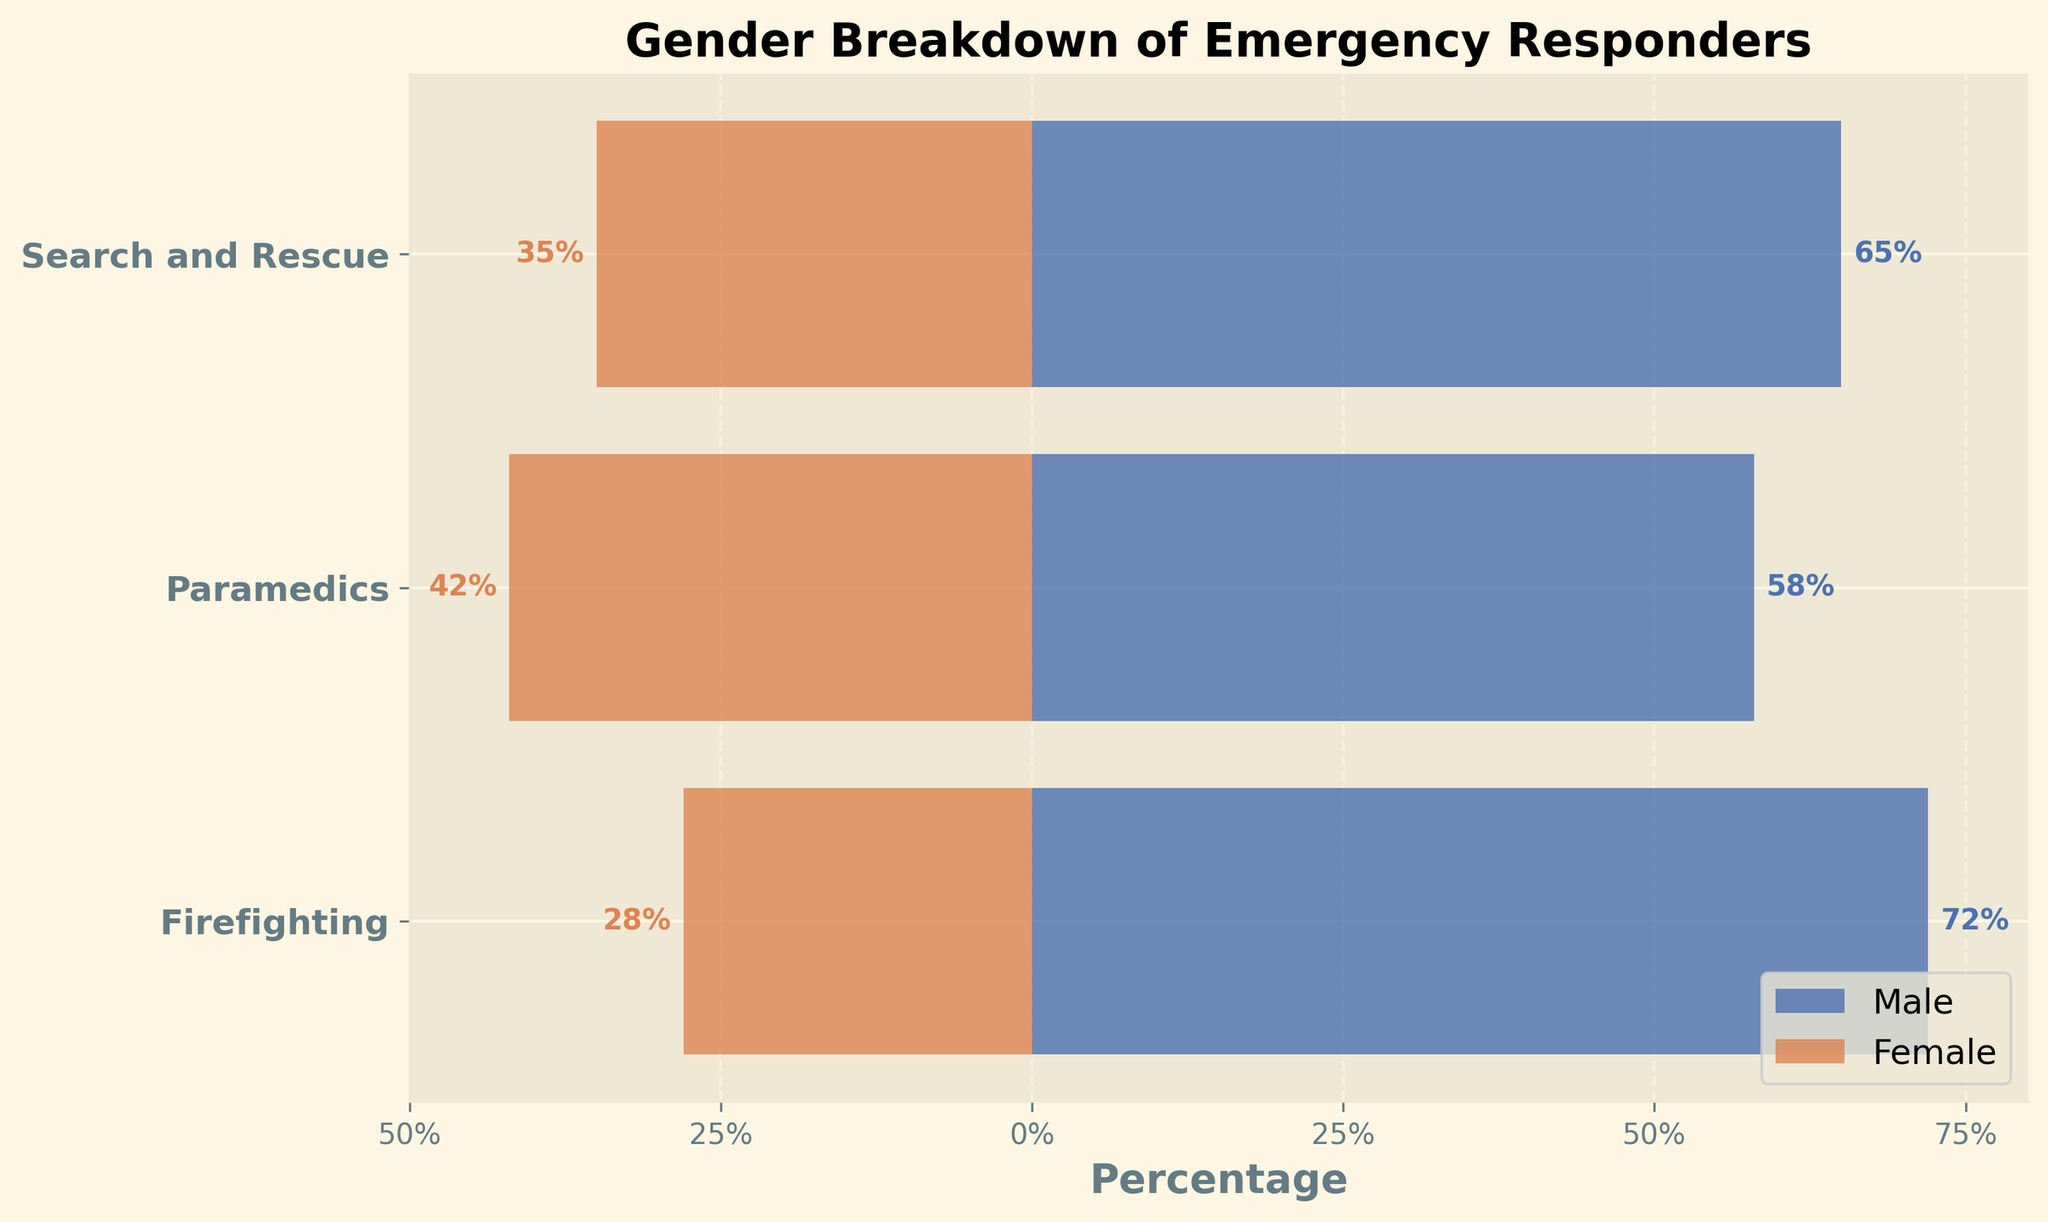what is the title of the plot? The title is typically located at the top of the figure and indicates the main subject of the plot. Here, it helps to clarify that the plot is about gender breakdown across different emergency responder specialties.
Answer: Gender Breakdown of Emergency Responders Which specialty has the highest percentage of males? To find this, we compare the percentages of males across all specialties. We look for the highest value among these numbers.
Answer: Firefighting Which specialty has the lowest percentage of females? We compare the percentages of females across all specialties and identify the lowest value among them.
Answer: Firefighting What's the gender split for the paramedics? The gender split is represented by the length of the horizontal bars for both males and females in the paramedics category. Males are 58% and females are 42%.
Answer: 58% male, 42% female How many percentage points more are male firefighters compared to female firefighters? We calculate this by subtracting the percentage of female firefighters from the percentage of male firefighters. 72% - 28% = 44%.
Answer: 44% Among the three specialties, which has the most balanced gender distribution? A balanced gender distribution means that the percentage of males and females is closest to 50-50. We compare the values for all three specialties to identify the one with minimal difference.
Answer: Paramedics On average, what is the percentage of females across all specialties? We add the percentages of females from all specialties and then divide by the number of specialties. (28% + 42% + 35%) / 3 = 35%.
Answer: 35% What is the difference in percentage points between male and female search and rescue responders? We find the difference by subtracting the percentage of female Search and Rescue responders from the percentage of male Search and Rescue responders. 65% - 35% = 30%.
Answer: 30% Which specialty shows the smallest gender disparity? We calculate the gender disparity by finding the absolute difference between male and female percentages for each specialty. We then compare these differences and identify the smallest one.
Answer: Search and Rescue How are the x-axis values labeled? The x-axis values are marked in percentages and typically represent the range of gender distribution. The labels help to indicate the extent of the male and female percentages.
Answer: Percentages (e.g., -50% to 80%) 